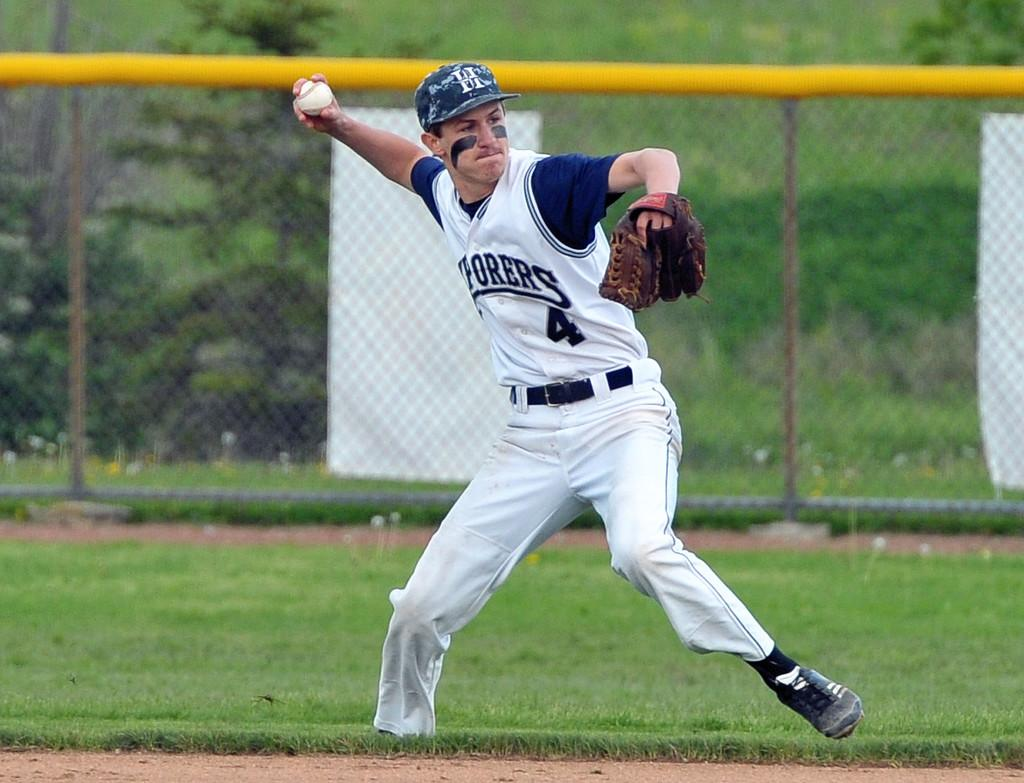Provide a one-sentence caption for the provided image. Pitcher number 4 getting ready to throw the ball. 